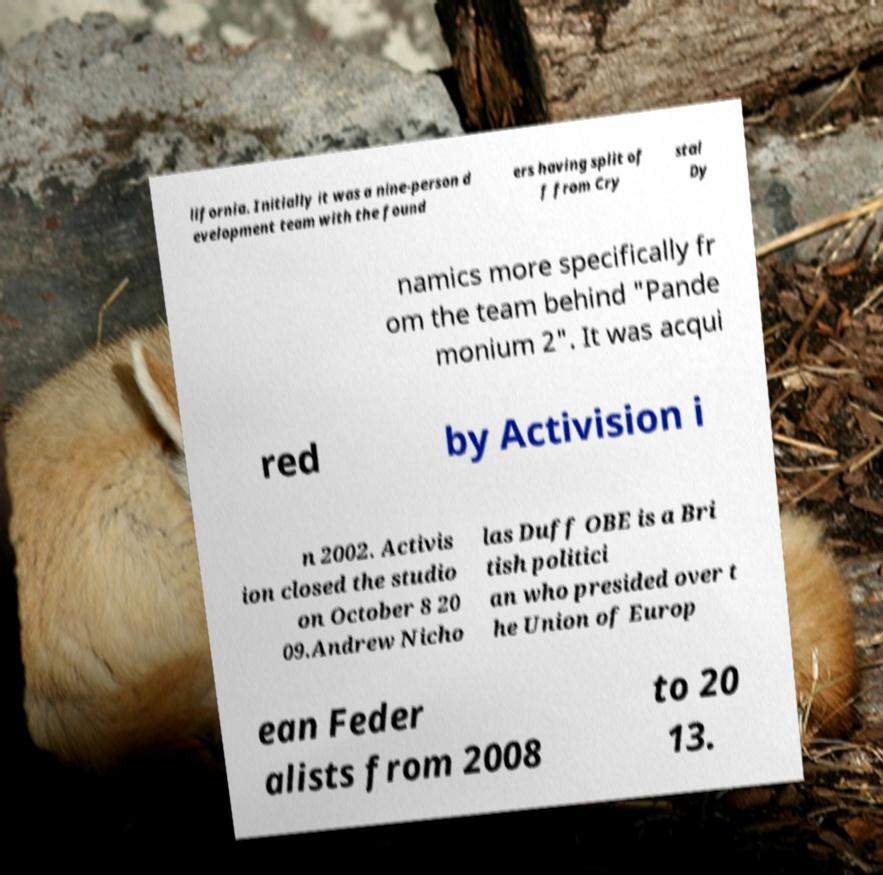For documentation purposes, I need the text within this image transcribed. Could you provide that? lifornia. Initially it was a nine-person d evelopment team with the found ers having split of f from Cry stal Dy namics more specifically fr om the team behind "Pande monium 2". It was acqui red by Activision i n 2002. Activis ion closed the studio on October 8 20 09.Andrew Nicho las Duff OBE is a Bri tish politici an who presided over t he Union of Europ ean Feder alists from 2008 to 20 13. 